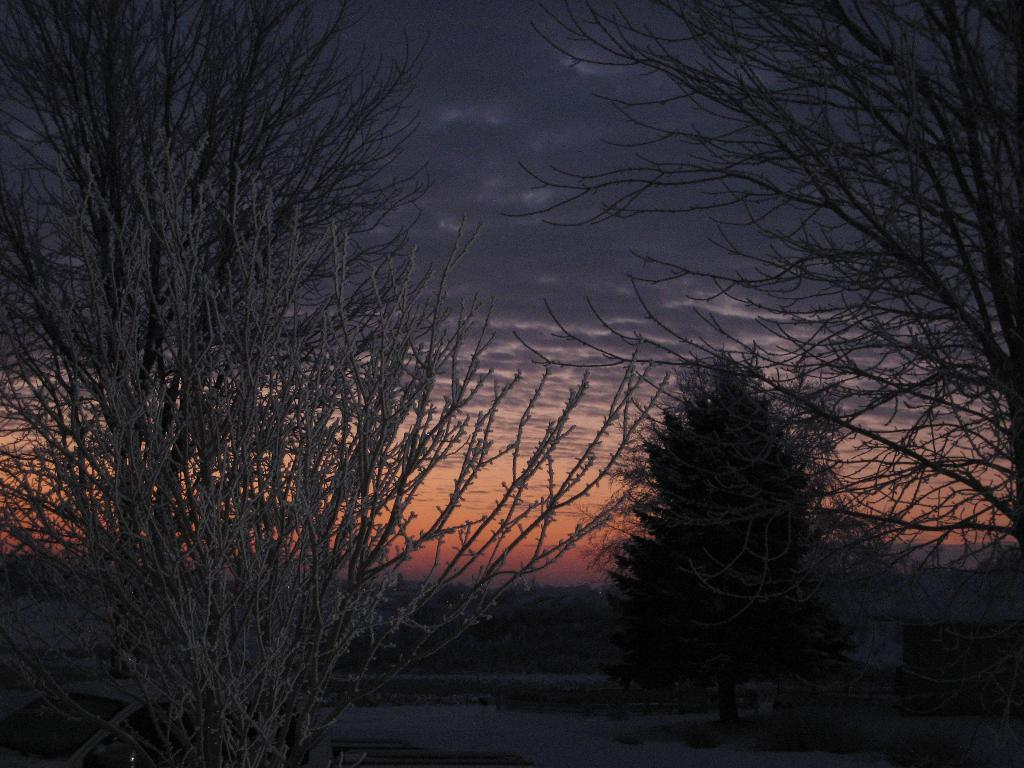What type of vegetation can be seen in the image? There are trees in the image. What is covering the trees in the image? The trees are covered with snow. What else can be seen in the background of the image? There is snow in the background of the image. What is visible at the top of the image? The sky is visible at the top of the image. How many cats can be seen playing with a spark in the image? There are no cats or sparks present in the image; it features trees covered with snow and a visible sky. 